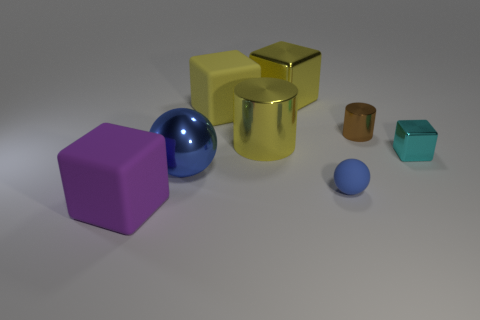Subtract all gray blocks. Subtract all yellow cylinders. How many blocks are left? 4 Add 1 small brown metal cylinders. How many objects exist? 9 Subtract all cylinders. How many objects are left? 6 Subtract 0 brown balls. How many objects are left? 8 Subtract all large gray rubber cylinders. Subtract all big cylinders. How many objects are left? 7 Add 1 blue metallic spheres. How many blue metallic spheres are left? 2 Add 7 cyan blocks. How many cyan blocks exist? 8 